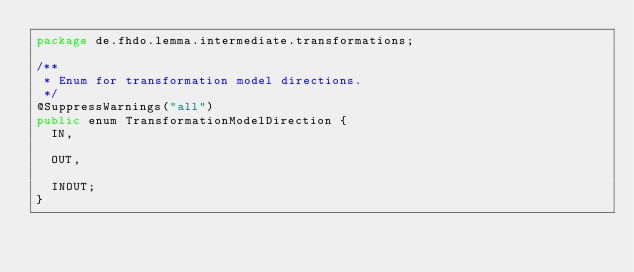<code> <loc_0><loc_0><loc_500><loc_500><_Java_>package de.fhdo.lemma.intermediate.transformations;

/**
 * Enum for transformation model directions.
 */
@SuppressWarnings("all")
public enum TransformationModelDirection {
  IN,
  
  OUT,
  
  INOUT;
}
</code> 